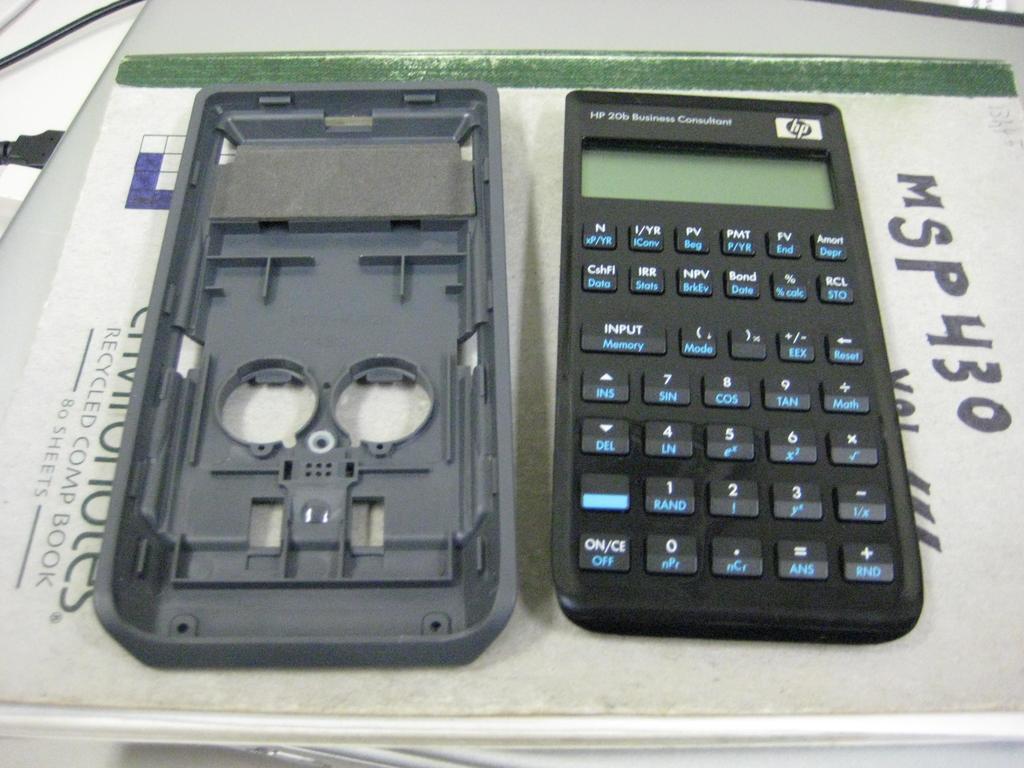What brand of calculator is this?
Keep it short and to the point. Hp. What button is on the bottom left?
Make the answer very short. On/ce off. 